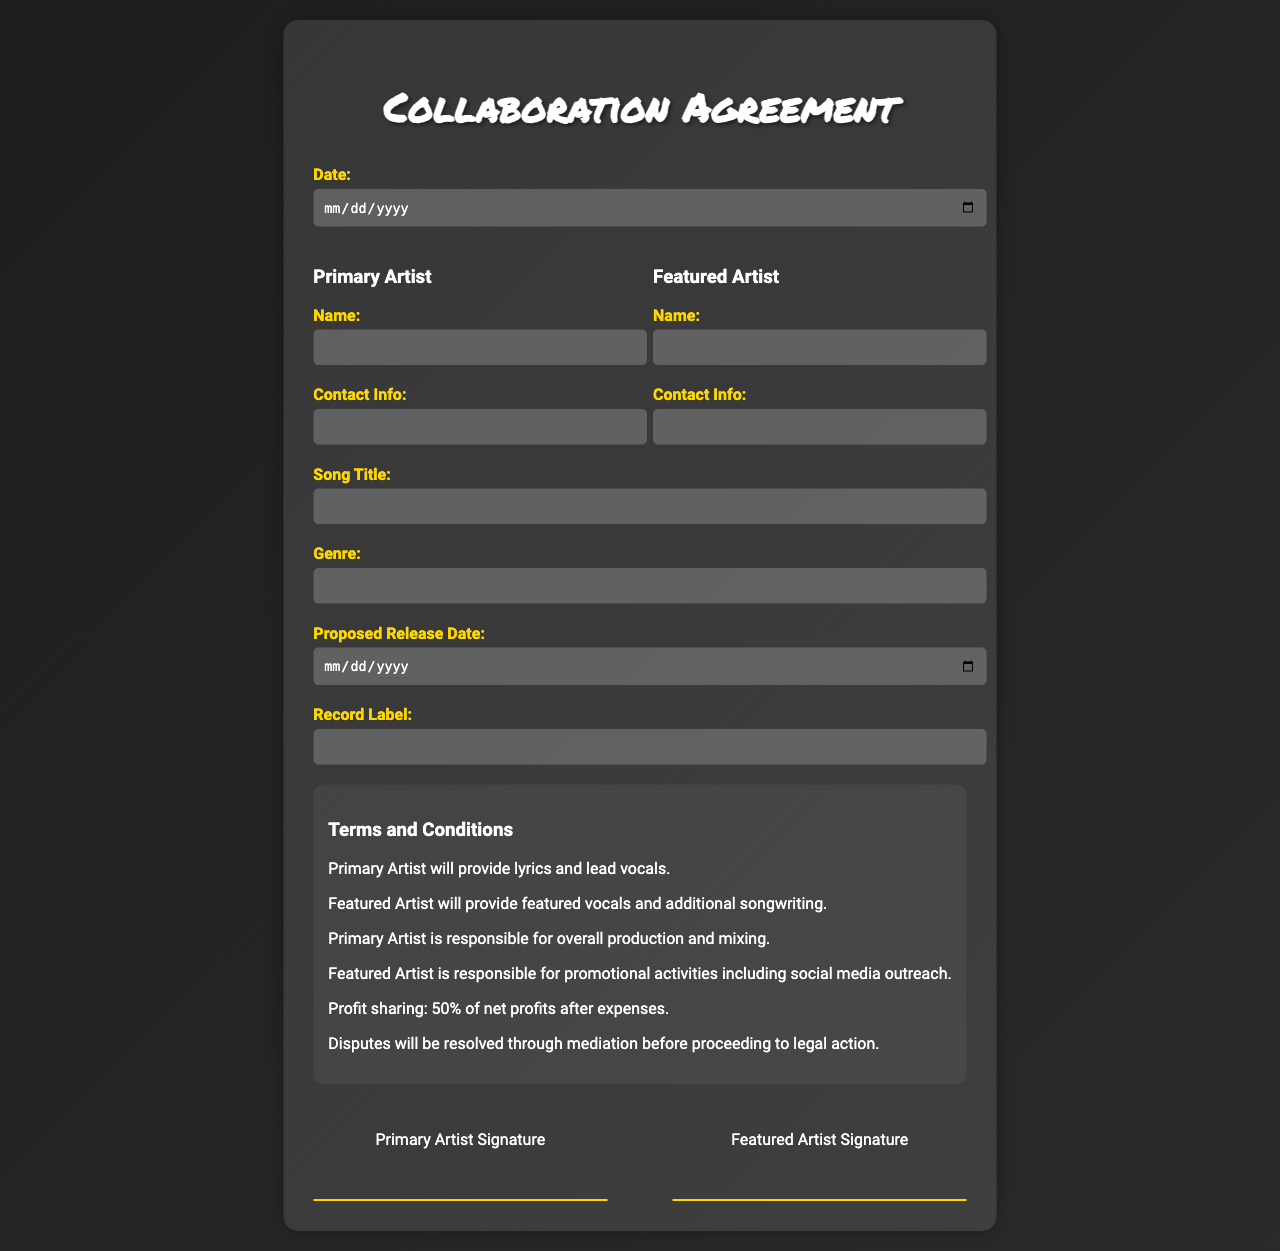What is the date of the agreement? The date of the agreement is specified in the form under the 'Date' field.
Answer: Date field What is the song title? The song title is required to be filled in the designated section of the form.
Answer: Song Title field Who is responsible for overall production and mixing? The roles and responsibilities are outlined in the terms section, stating who handles production and mixing.
Answer: Primary Artist What percentage of net profits is shared? This information is mentioned in the profit-sharing clause within the terms and conditions.
Answer: 50% What is the proposed release date? The form includes a field specifically for the proposed release date of the song.
Answer: Proposed Release Date field What is the record label's name? The form contains a section where the record label's name must be provided.
Answer: Record Label field Who is responsible for promotional activities? The terms section clearly mentions the responsibilities assigned to both artists, including promotional duties.
Answer: Featured Artist What type of agreement is this? The title at the top of the document specifies this type of form.
Answer: Collaboration Agreement What is the artist's responsibility regarding lyrics? The terms state what the primary artist is expected to contribute to the collaboration.
Answer: Provide lyrics and lead vocals 